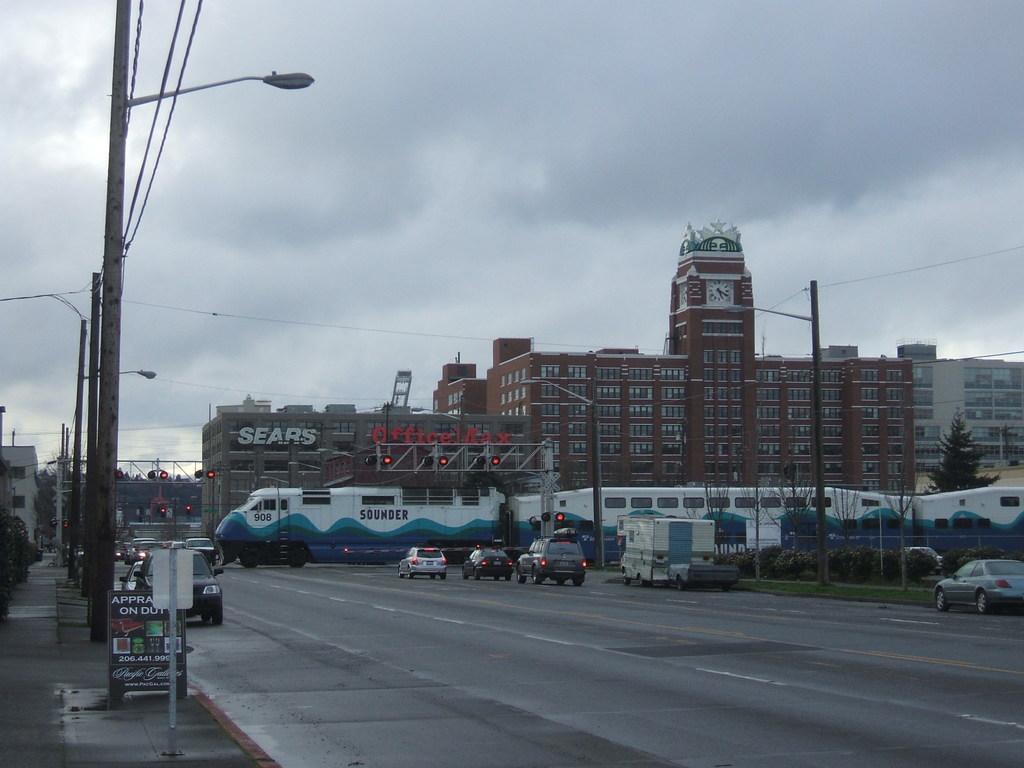Can you describe this image briefly? In this image there is a road in the middle on which there are vehicles. In the middle there is a train on the road. In the background there are tall buildings one beside the other. On the left side there are electric poles on the footpath. To the poles there are lights and wires. In the middle we can see there are signal lights on the road. At the top there is the sky. On the right side there is a fence. Beside the fence there are pants. 